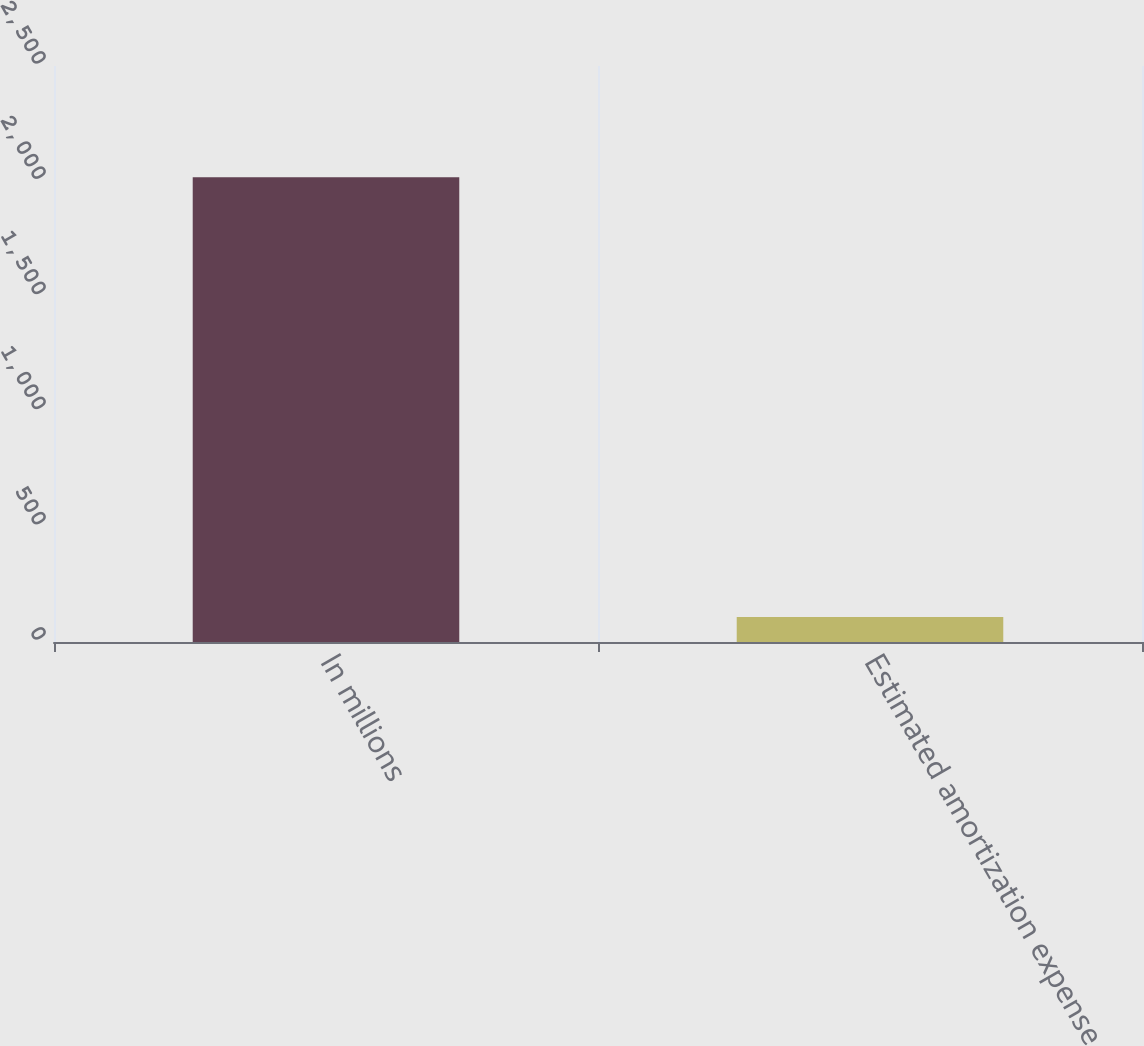<chart> <loc_0><loc_0><loc_500><loc_500><bar_chart><fcel>In millions<fcel>Estimated amortization expense<nl><fcel>2017<fcel>109<nl></chart> 